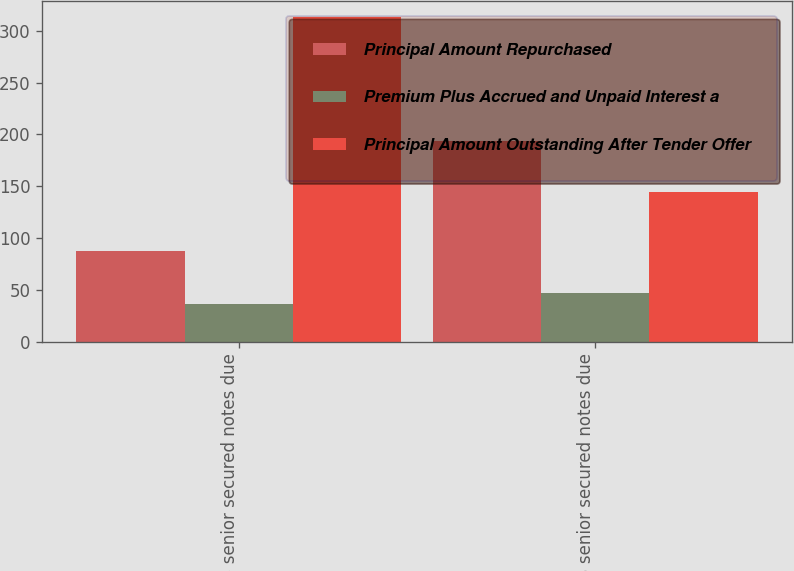Convert chart to OTSL. <chart><loc_0><loc_0><loc_500><loc_500><stacked_bar_chart><ecel><fcel>975 senior secured notes due<fcel>625 senior secured notes due<nl><fcel>Principal Amount Repurchased<fcel>87<fcel>194<nl><fcel>Premium Plus Accrued and Unpaid Interest a<fcel>36<fcel>47<nl><fcel>Principal Amount Outstanding After Tender Offer<fcel>313<fcel>144<nl></chart> 